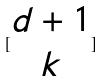Convert formula to latex. <formula><loc_0><loc_0><loc_500><loc_500>[ \begin{matrix} d + 1 \\ k \end{matrix} ]</formula> 